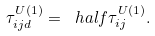Convert formula to latex. <formula><loc_0><loc_0><loc_500><loc_500>\tau _ { i j d } ^ { U ( 1 ) } = \ h a l f \tau _ { i j } ^ { U ( 1 ) } .</formula> 